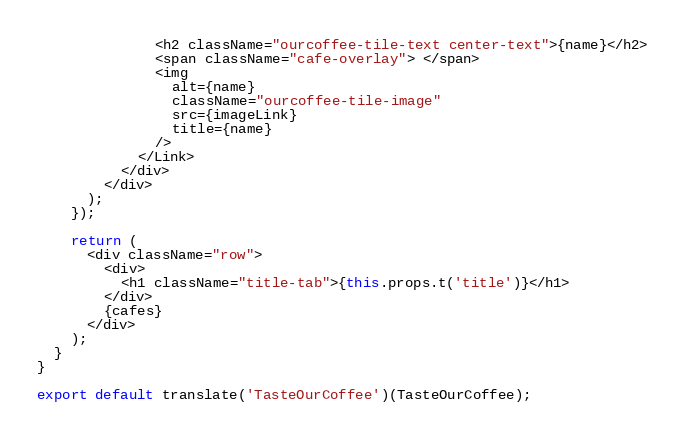<code> <loc_0><loc_0><loc_500><loc_500><_JavaScript_>              <h2 className="ourcoffee-tile-text center-text">{name}</h2>
              <span className="cafe-overlay"> </span>
              <img
                alt={name}
                className="ourcoffee-tile-image"
                src={imageLink}
                title={name}
              />
            </Link>
          </div>
        </div>
      );
    });

    return (
      <div className="row">
        <div>
          <h1 className="title-tab">{this.props.t('title')}</h1>
        </div>
        {cafes}
      </div>
    );
  }
}

export default translate('TasteOurCoffee')(TasteOurCoffee);
</code> 